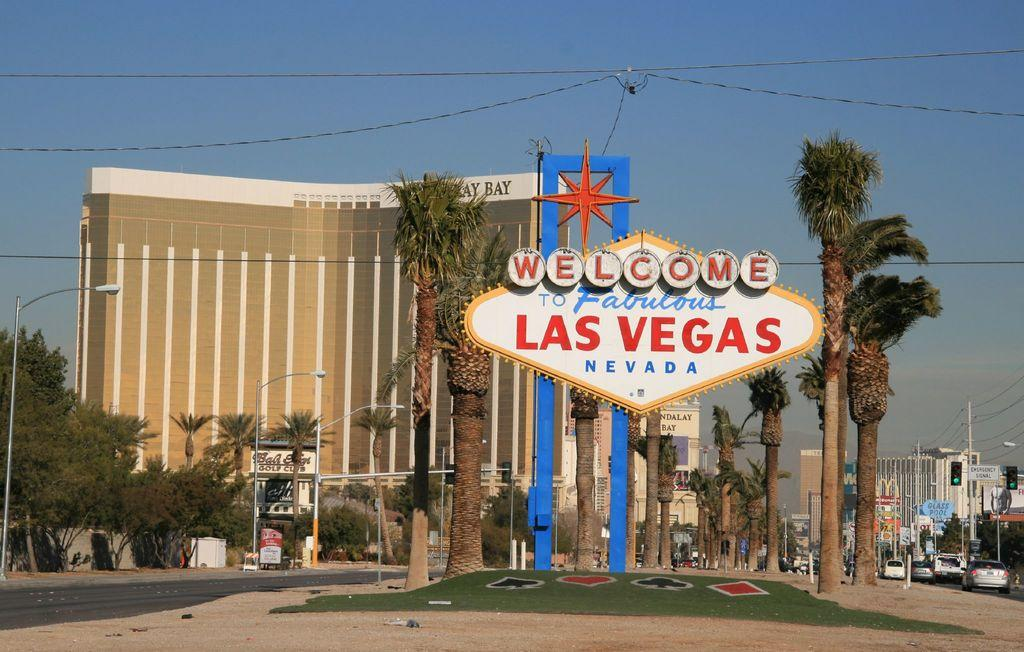What type of vegetation can be seen in the image? There are trees in the image. What type of structures are present in the image? There are buildings in the image. What objects can be seen supporting wires or cables in the image? There are poles in the image. What type of advertisements or announcements are visible in the image? There are hoardings in the image. What can be seen in the background of the image? In the background, there are vehicles and traffic lights. What type of signs are visible in the background? Sign boards are visible in the background. How many eggs are visible on the trees in the image? There are no eggs visible on the trees in the image. What type of coach can be seen driving through the background? There is no coach present in the image; only vehicles and traffic lights are visible in the background. 